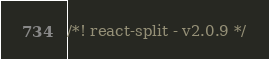Convert code to text. <code><loc_0><loc_0><loc_500><loc_500><_JavaScript_>/*! react-split - v2.0.9 */</code> 